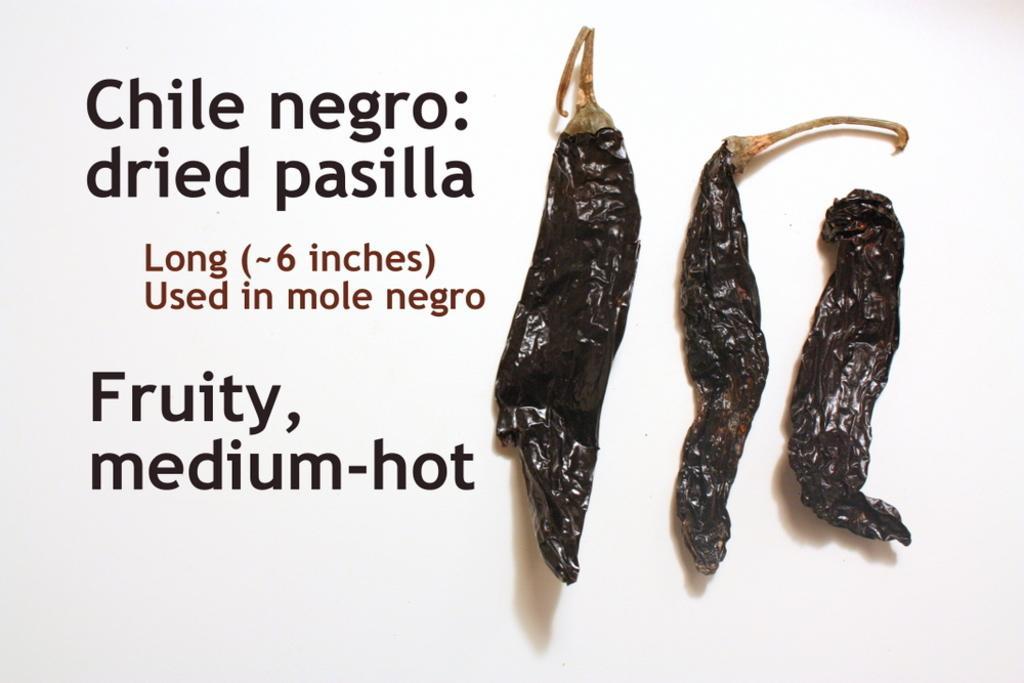In one or two sentences, can you explain what this image depicts? This picture shows dry chillies and we see text and white background. 